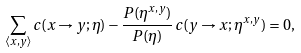<formula> <loc_0><loc_0><loc_500><loc_500>\sum _ { \langle x , y \rangle } c ( x \to y ; \eta ) - \frac { P ( \eta ^ { x , y } ) } { P ( \eta ) } \, c ( y \to x ; \eta ^ { x , y } ) = 0 ,</formula> 